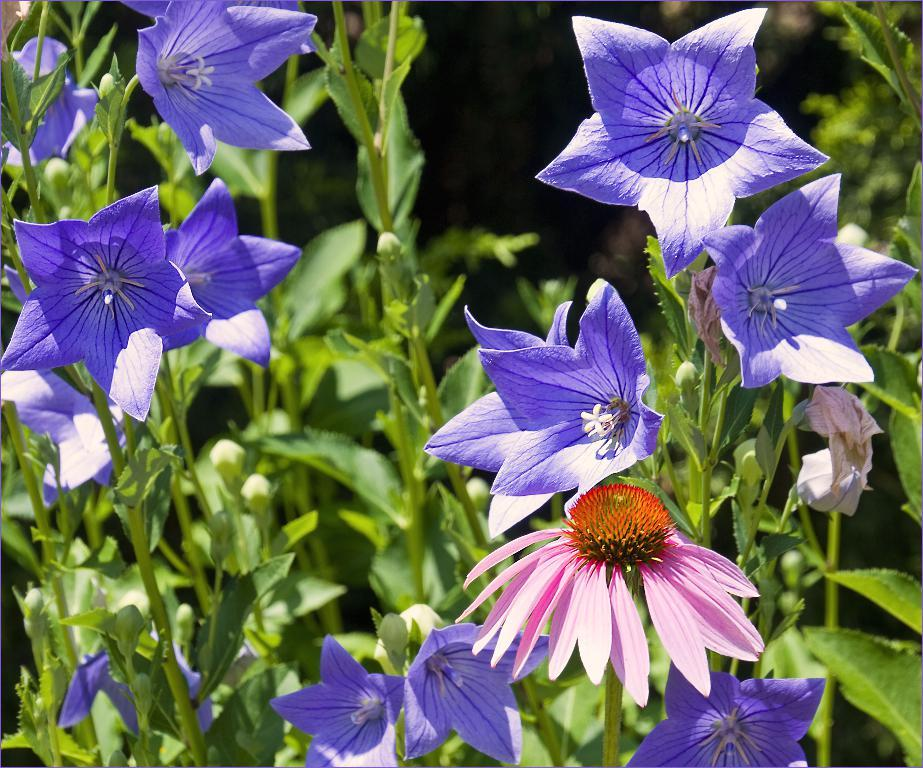What type of plant life is visible in the image? There are flowers, stems, and leaves in the image. Can you describe the different parts of the plants in the image? The flowers are the colorful parts of the plants, the stems are the long, thin structures that support the flowers, and the leaves are the flat, green parts that help the plants absorb sunlight. What type of dress is the manager wearing in the image? There is no manager or dress present in the image; it features flowers, stems, and leaves. 